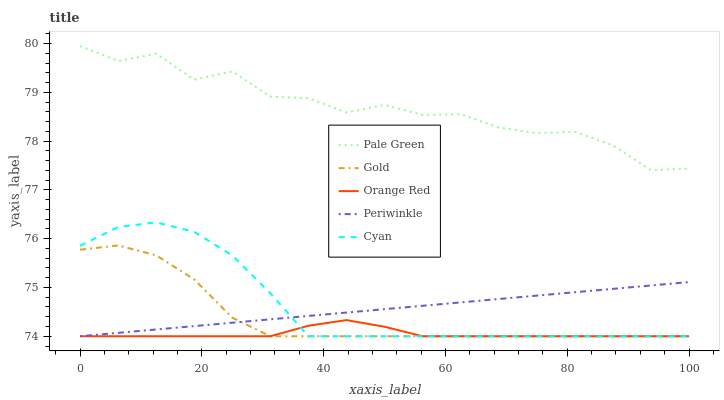Does Orange Red have the minimum area under the curve?
Answer yes or no. Yes. Does Pale Green have the maximum area under the curve?
Answer yes or no. Yes. Does Periwinkle have the minimum area under the curve?
Answer yes or no. No. Does Periwinkle have the maximum area under the curve?
Answer yes or no. No. Is Periwinkle the smoothest?
Answer yes or no. Yes. Is Pale Green the roughest?
Answer yes or no. Yes. Is Pale Green the smoothest?
Answer yes or no. No. Is Periwinkle the roughest?
Answer yes or no. No. Does Cyan have the lowest value?
Answer yes or no. Yes. Does Pale Green have the lowest value?
Answer yes or no. No. Does Pale Green have the highest value?
Answer yes or no. Yes. Does Periwinkle have the highest value?
Answer yes or no. No. Is Periwinkle less than Pale Green?
Answer yes or no. Yes. Is Pale Green greater than Orange Red?
Answer yes or no. Yes. Does Orange Red intersect Gold?
Answer yes or no. Yes. Is Orange Red less than Gold?
Answer yes or no. No. Is Orange Red greater than Gold?
Answer yes or no. No. Does Periwinkle intersect Pale Green?
Answer yes or no. No. 